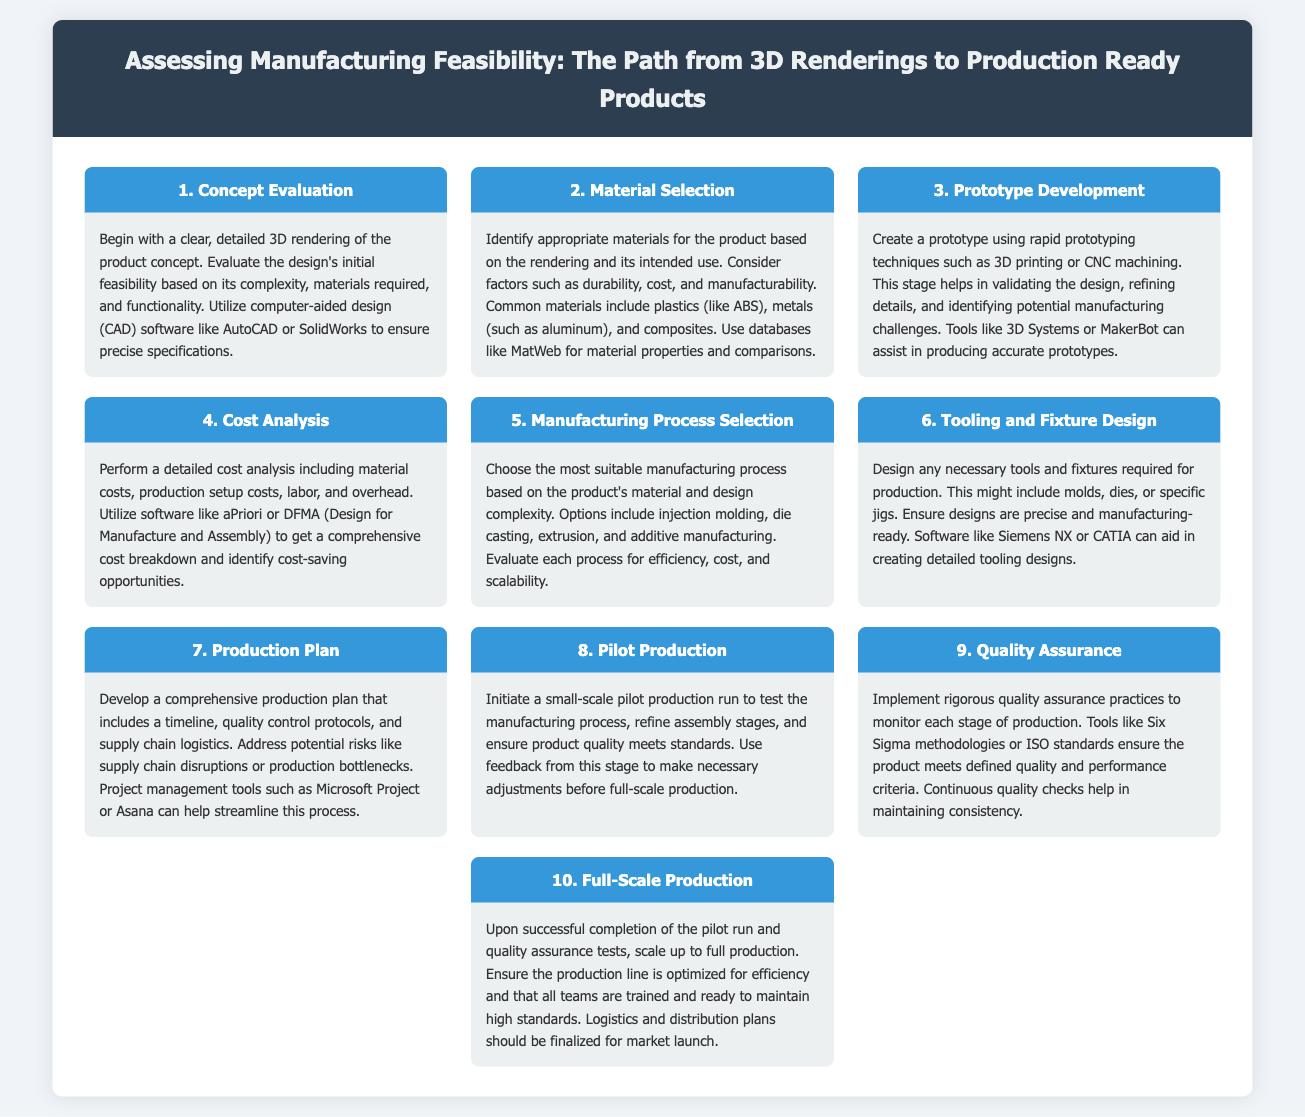What is the first step in assessing manufacturing feasibility? The first step is to evaluate the concept with a detailed 3D rendering and check the design's initial feasibility.
Answer: Concept Evaluation What tool is suggested for creating prototypes? The document mentions 3D Systems or MakerBot as tools that can assist in producing accurate prototypes.
Answer: 3D Systems or MakerBot What factor is considered in material selection? Factors such as durability, cost, and manufacturability are considered when selecting appropriate materials.
Answer: Durability, cost, and manufacturability What is conducted during the pilot production stage? Initiating a small-scale pilot production run is highlighted to test the manufacturing process and ensure product quality.
Answer: Small-scale pilot production run Which software is recommended for cost analysis? aPriori or DFMA (Design for Manufacture and Assembly) software is recommended for detailed cost analysis.
Answer: aPriori or DFMA What is the final step before full-scale production? The final step before scaling up is ensuring that all quality assurance tests have been completed successfully.
Answer: Quality Assurance What is an important tool for developing a production plan? Project management tools such as Microsoft Project or Asana are important for developing a comprehensive production plan.
Answer: Microsoft Project or Asana 